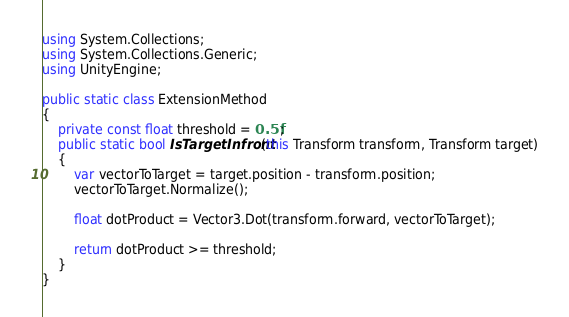Convert code to text. <code><loc_0><loc_0><loc_500><loc_500><_C#_>using System.Collections;
using System.Collections.Generic;
using UnityEngine;

public static class ExtensionMethod
{
    private const float threshold = 0.5f;
    public static bool IsTargetInfront(this Transform transform, Transform target)
    {
        var vectorToTarget = target.position - transform.position;
        vectorToTarget.Normalize();

        float dotProduct = Vector3.Dot(transform.forward, vectorToTarget);

        return dotProduct >= threshold;
    }
}
</code> 